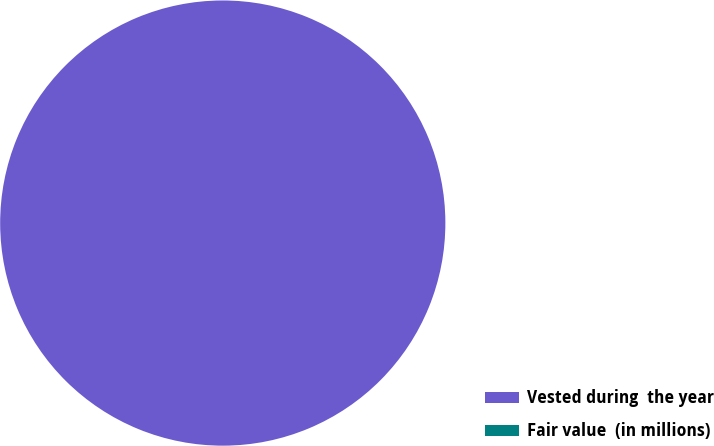Convert chart. <chart><loc_0><loc_0><loc_500><loc_500><pie_chart><fcel>Vested during  the year<fcel>Fair value  (in millions)<nl><fcel>100.0%<fcel>0.0%<nl></chart> 